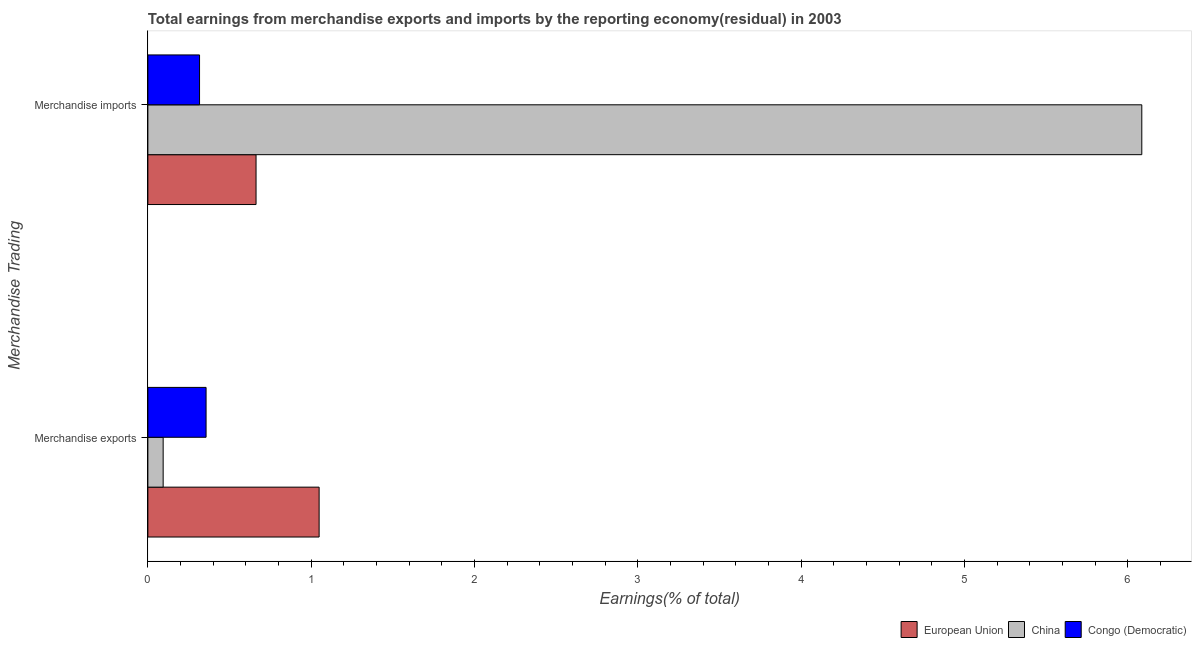How many groups of bars are there?
Ensure brevity in your answer.  2. What is the earnings from merchandise imports in Congo (Democratic)?
Offer a terse response. 0.32. Across all countries, what is the maximum earnings from merchandise imports?
Offer a very short reply. 6.09. Across all countries, what is the minimum earnings from merchandise exports?
Offer a very short reply. 0.09. What is the total earnings from merchandise exports in the graph?
Your answer should be compact. 1.5. What is the difference between the earnings from merchandise exports in Congo (Democratic) and that in European Union?
Keep it short and to the point. -0.69. What is the difference between the earnings from merchandise exports in European Union and the earnings from merchandise imports in Congo (Democratic)?
Provide a short and direct response. 0.73. What is the average earnings from merchandise exports per country?
Offer a very short reply. 0.5. What is the difference between the earnings from merchandise exports and earnings from merchandise imports in European Union?
Offer a very short reply. 0.39. In how many countries, is the earnings from merchandise imports greater than 2.6 %?
Make the answer very short. 1. What is the ratio of the earnings from merchandise exports in European Union to that in China?
Give a very brief answer. 11.2. Is the earnings from merchandise exports in Congo (Democratic) less than that in China?
Make the answer very short. No. In how many countries, is the earnings from merchandise imports greater than the average earnings from merchandise imports taken over all countries?
Offer a terse response. 1. What does the 3rd bar from the top in Merchandise imports represents?
Provide a succinct answer. European Union. What does the 3rd bar from the bottom in Merchandise imports represents?
Keep it short and to the point. Congo (Democratic). What is the difference between two consecutive major ticks on the X-axis?
Your answer should be compact. 1. Are the values on the major ticks of X-axis written in scientific E-notation?
Provide a succinct answer. No. Does the graph contain any zero values?
Your answer should be compact. No. Does the graph contain grids?
Give a very brief answer. No. How many legend labels are there?
Offer a very short reply. 3. What is the title of the graph?
Provide a succinct answer. Total earnings from merchandise exports and imports by the reporting economy(residual) in 2003. Does "Uzbekistan" appear as one of the legend labels in the graph?
Offer a very short reply. No. What is the label or title of the X-axis?
Make the answer very short. Earnings(% of total). What is the label or title of the Y-axis?
Provide a succinct answer. Merchandise Trading. What is the Earnings(% of total) in European Union in Merchandise exports?
Offer a very short reply. 1.05. What is the Earnings(% of total) of China in Merchandise exports?
Keep it short and to the point. 0.09. What is the Earnings(% of total) in Congo (Democratic) in Merchandise exports?
Keep it short and to the point. 0.36. What is the Earnings(% of total) of European Union in Merchandise imports?
Ensure brevity in your answer.  0.66. What is the Earnings(% of total) in China in Merchandise imports?
Make the answer very short. 6.09. What is the Earnings(% of total) in Congo (Democratic) in Merchandise imports?
Keep it short and to the point. 0.32. Across all Merchandise Trading, what is the maximum Earnings(% of total) of European Union?
Give a very brief answer. 1.05. Across all Merchandise Trading, what is the maximum Earnings(% of total) in China?
Keep it short and to the point. 6.09. Across all Merchandise Trading, what is the maximum Earnings(% of total) in Congo (Democratic)?
Make the answer very short. 0.36. Across all Merchandise Trading, what is the minimum Earnings(% of total) in European Union?
Your response must be concise. 0.66. Across all Merchandise Trading, what is the minimum Earnings(% of total) of China?
Provide a succinct answer. 0.09. Across all Merchandise Trading, what is the minimum Earnings(% of total) in Congo (Democratic)?
Offer a very short reply. 0.32. What is the total Earnings(% of total) of European Union in the graph?
Provide a short and direct response. 1.71. What is the total Earnings(% of total) in China in the graph?
Your response must be concise. 6.18. What is the total Earnings(% of total) in Congo (Democratic) in the graph?
Give a very brief answer. 0.67. What is the difference between the Earnings(% of total) in European Union in Merchandise exports and that in Merchandise imports?
Your response must be concise. 0.39. What is the difference between the Earnings(% of total) of China in Merchandise exports and that in Merchandise imports?
Your answer should be very brief. -5.99. What is the difference between the Earnings(% of total) in Congo (Democratic) in Merchandise exports and that in Merchandise imports?
Make the answer very short. 0.04. What is the difference between the Earnings(% of total) of European Union in Merchandise exports and the Earnings(% of total) of China in Merchandise imports?
Your response must be concise. -5.04. What is the difference between the Earnings(% of total) of European Union in Merchandise exports and the Earnings(% of total) of Congo (Democratic) in Merchandise imports?
Give a very brief answer. 0.73. What is the difference between the Earnings(% of total) in China in Merchandise exports and the Earnings(% of total) in Congo (Democratic) in Merchandise imports?
Provide a succinct answer. -0.22. What is the average Earnings(% of total) of European Union per Merchandise Trading?
Offer a very short reply. 0.86. What is the average Earnings(% of total) of China per Merchandise Trading?
Keep it short and to the point. 3.09. What is the average Earnings(% of total) in Congo (Democratic) per Merchandise Trading?
Ensure brevity in your answer.  0.34. What is the difference between the Earnings(% of total) of European Union and Earnings(% of total) of China in Merchandise exports?
Your answer should be compact. 0.95. What is the difference between the Earnings(% of total) in European Union and Earnings(% of total) in Congo (Democratic) in Merchandise exports?
Offer a very short reply. 0.69. What is the difference between the Earnings(% of total) in China and Earnings(% of total) in Congo (Democratic) in Merchandise exports?
Keep it short and to the point. -0.26. What is the difference between the Earnings(% of total) of European Union and Earnings(% of total) of China in Merchandise imports?
Offer a terse response. -5.42. What is the difference between the Earnings(% of total) in European Union and Earnings(% of total) in Congo (Democratic) in Merchandise imports?
Your response must be concise. 0.35. What is the difference between the Earnings(% of total) of China and Earnings(% of total) of Congo (Democratic) in Merchandise imports?
Provide a succinct answer. 5.77. What is the ratio of the Earnings(% of total) in European Union in Merchandise exports to that in Merchandise imports?
Offer a very short reply. 1.58. What is the ratio of the Earnings(% of total) in China in Merchandise exports to that in Merchandise imports?
Make the answer very short. 0.02. What is the ratio of the Earnings(% of total) in Congo (Democratic) in Merchandise exports to that in Merchandise imports?
Give a very brief answer. 1.13. What is the difference between the highest and the second highest Earnings(% of total) in European Union?
Ensure brevity in your answer.  0.39. What is the difference between the highest and the second highest Earnings(% of total) in China?
Your answer should be very brief. 5.99. What is the difference between the highest and the second highest Earnings(% of total) of Congo (Democratic)?
Make the answer very short. 0.04. What is the difference between the highest and the lowest Earnings(% of total) of European Union?
Your answer should be very brief. 0.39. What is the difference between the highest and the lowest Earnings(% of total) of China?
Ensure brevity in your answer.  5.99. What is the difference between the highest and the lowest Earnings(% of total) of Congo (Democratic)?
Offer a terse response. 0.04. 